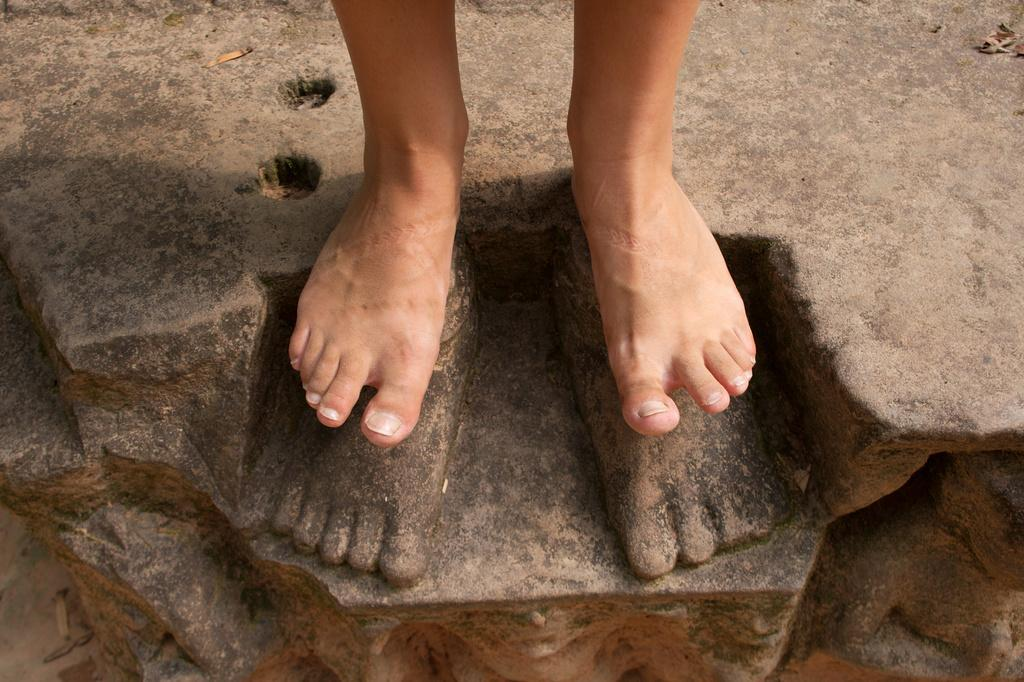What is the main subject of the image? There is a person in the image. Can you describe the person's position or location in the image? The person is standing on a rock. How many trucks can be seen in the image? There are no trucks present in the image. What type of string is being used by the person in the image? There is no string visible in the image. 